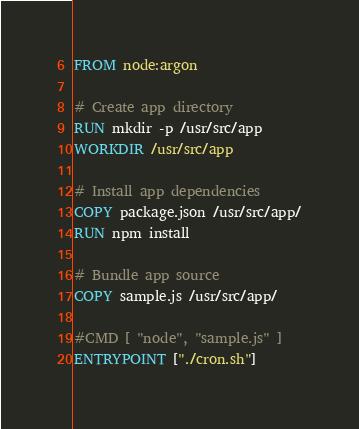<code> <loc_0><loc_0><loc_500><loc_500><_Dockerfile_>FROM node:argon

# Create app directory
RUN mkdir -p /usr/src/app
WORKDIR /usr/src/app

# Install app dependencies
COPY package.json /usr/src/app/
RUN npm install

# Bundle app source
COPY sample.js /usr/src/app/

#CMD [ "node", "sample.js" ]
ENTRYPOINT ["./cron.sh"]
</code> 